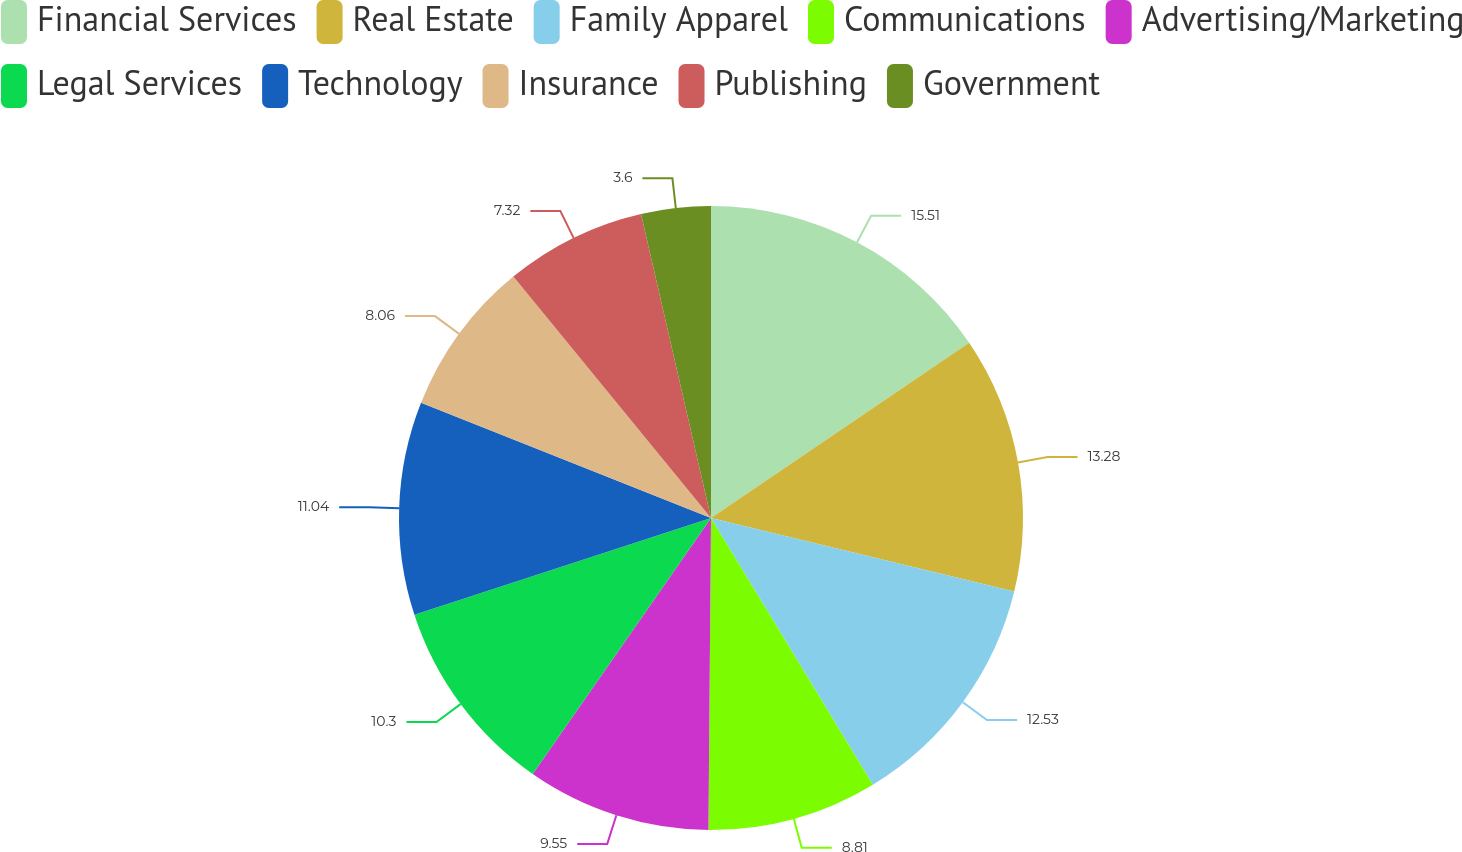<chart> <loc_0><loc_0><loc_500><loc_500><pie_chart><fcel>Financial Services<fcel>Real Estate<fcel>Family Apparel<fcel>Communications<fcel>Advertising/Marketing<fcel>Legal Services<fcel>Technology<fcel>Insurance<fcel>Publishing<fcel>Government<nl><fcel>15.51%<fcel>13.28%<fcel>12.53%<fcel>8.81%<fcel>9.55%<fcel>10.3%<fcel>11.04%<fcel>8.06%<fcel>7.32%<fcel>3.6%<nl></chart> 